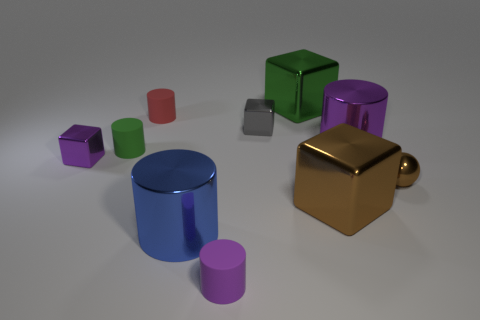Describe the lighting in the scene. The lighting in the image is soft and diffused, coming from above and casting subtle shadows beneath each object. This type of lighting minimizes harsh shadows and highlights, which enhances the perception of the objects’ colors and materials. 